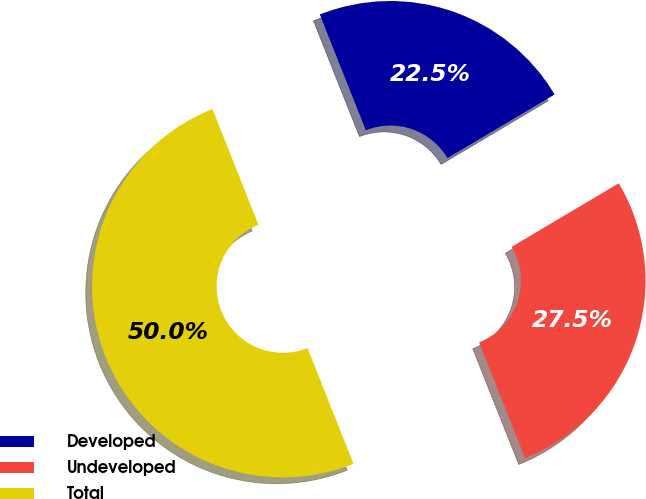<chart> <loc_0><loc_0><loc_500><loc_500><pie_chart><fcel>Developed<fcel>Undeveloped<fcel>Total<nl><fcel>22.5%<fcel>27.5%<fcel>50.0%<nl></chart> 